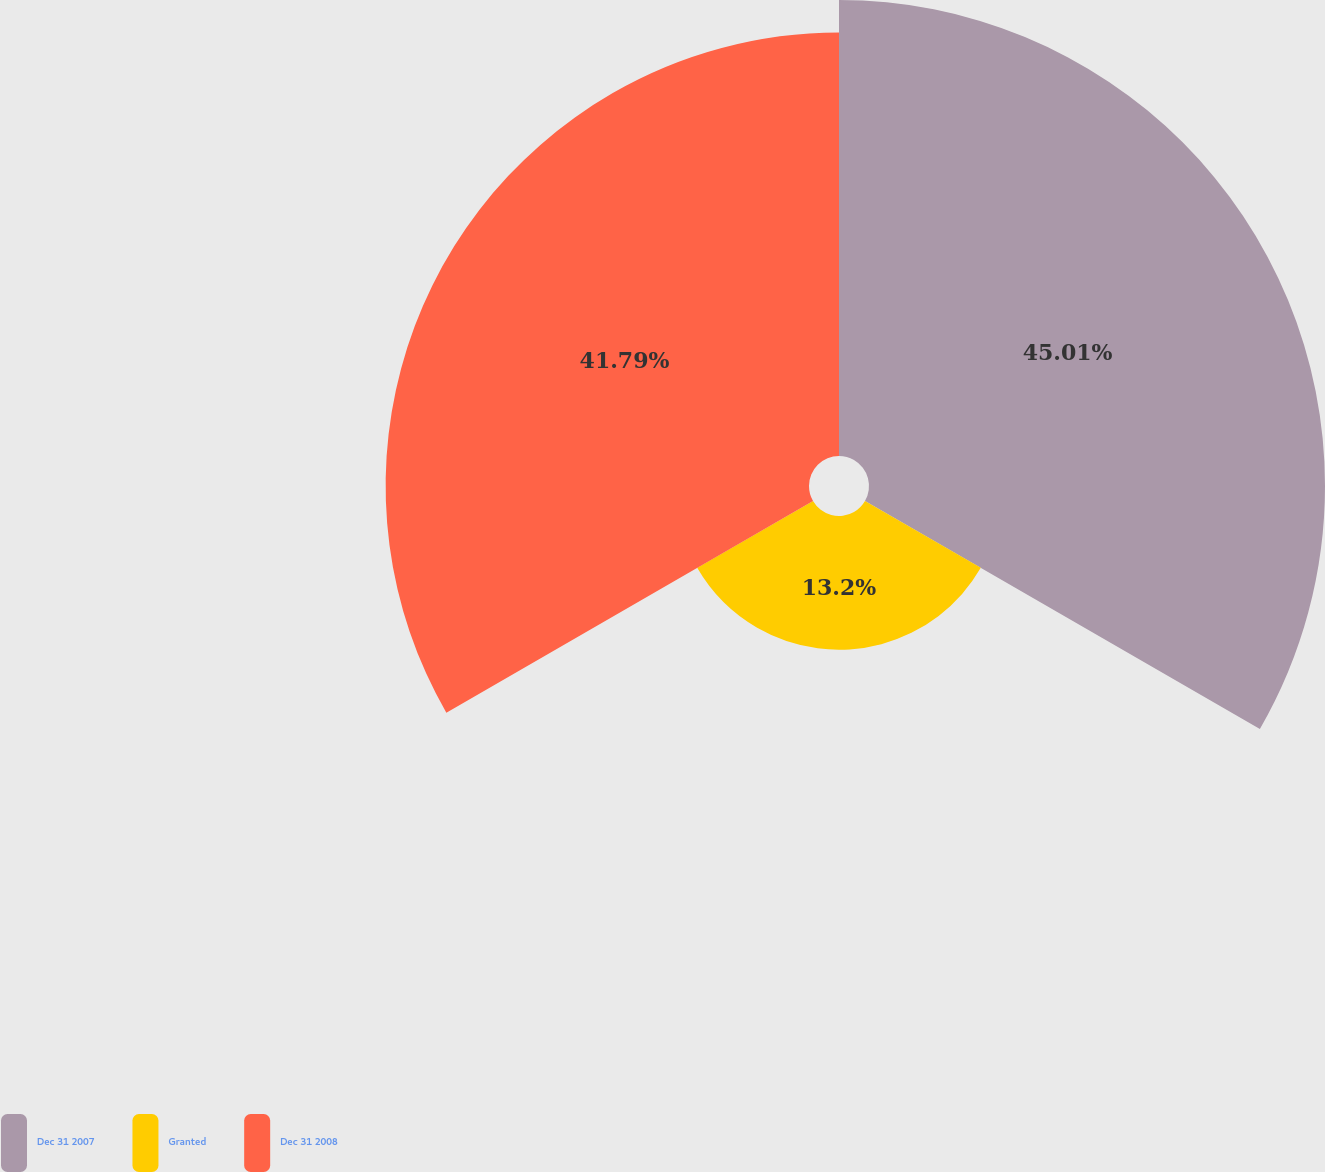Convert chart to OTSL. <chart><loc_0><loc_0><loc_500><loc_500><pie_chart><fcel>Dec 31 2007<fcel>Granted<fcel>Dec 31 2008<nl><fcel>45.01%<fcel>13.2%<fcel>41.79%<nl></chart> 